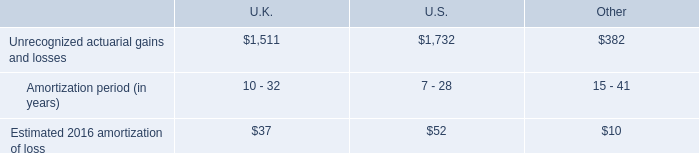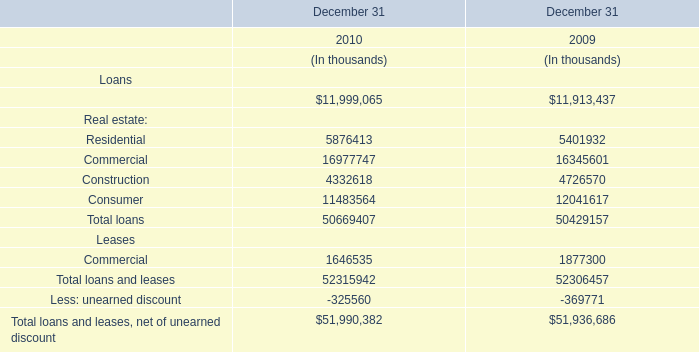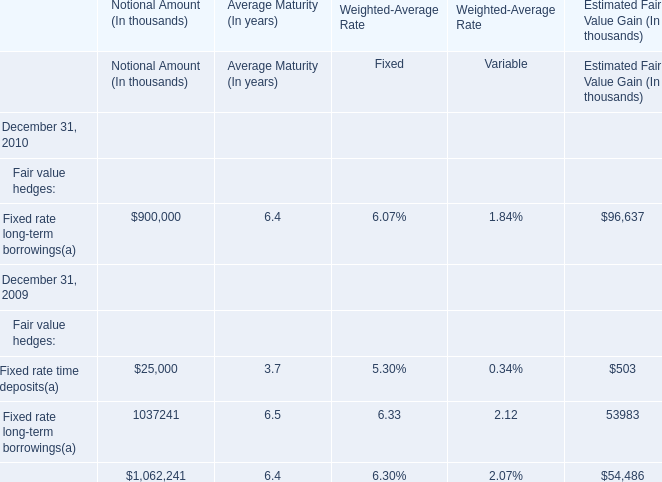Which year is Weighted-Average Rate in terms of Fixed for Fixed rate long-term borrowings lower as of December 31? 
Answer: 2010. 